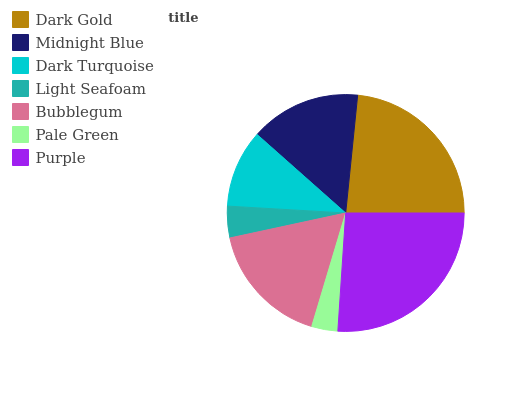Is Pale Green the minimum?
Answer yes or no. Yes. Is Purple the maximum?
Answer yes or no. Yes. Is Midnight Blue the minimum?
Answer yes or no. No. Is Midnight Blue the maximum?
Answer yes or no. No. Is Dark Gold greater than Midnight Blue?
Answer yes or no. Yes. Is Midnight Blue less than Dark Gold?
Answer yes or no. Yes. Is Midnight Blue greater than Dark Gold?
Answer yes or no. No. Is Dark Gold less than Midnight Blue?
Answer yes or no. No. Is Midnight Blue the high median?
Answer yes or no. Yes. Is Midnight Blue the low median?
Answer yes or no. Yes. Is Dark Gold the high median?
Answer yes or no. No. Is Dark Gold the low median?
Answer yes or no. No. 